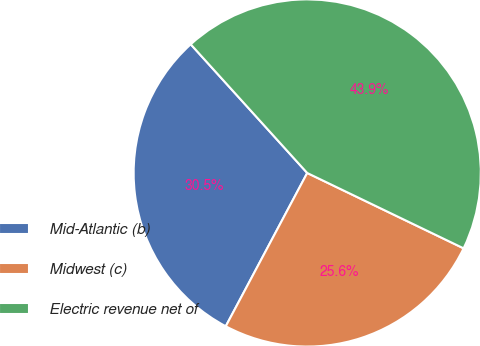<chart> <loc_0><loc_0><loc_500><loc_500><pie_chart><fcel>Mid-Atlantic (b)<fcel>Midwest (c)<fcel>Electric revenue net of<nl><fcel>30.52%<fcel>25.63%<fcel>43.86%<nl></chart> 